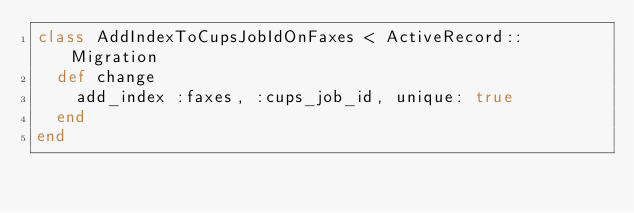<code> <loc_0><loc_0><loc_500><loc_500><_Ruby_>class AddIndexToCupsJobIdOnFaxes < ActiveRecord::Migration
  def change
    add_index :faxes, :cups_job_id, unique: true
  end
end
</code> 